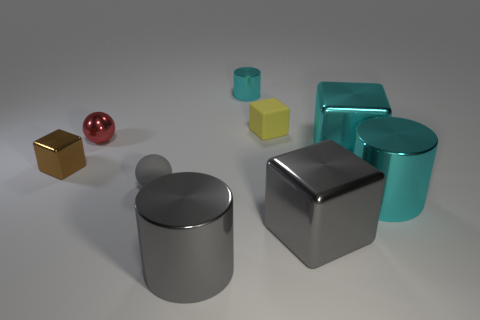What number of cyan cylinders are the same size as the brown metal cube?
Your answer should be very brief. 1. There is a big gray metallic object to the right of the small yellow matte thing; does it have the same shape as the matte object that is to the left of the small metallic cylinder?
Your answer should be very brief. No. What color is the small matte object to the right of the small object that is behind the yellow thing?
Provide a short and direct response. Yellow. What color is the other object that is the same shape as the red object?
Provide a short and direct response. Gray. The gray metal thing that is the same shape as the brown thing is what size?
Offer a very short reply. Large. There is a big gray thing right of the small cylinder; what material is it?
Ensure brevity in your answer.  Metal. Is the number of gray shiny objects behind the tiny brown block less than the number of purple metal objects?
Provide a short and direct response. No. There is a cyan object that is on the left side of the big thing that is behind the big cyan cylinder; what shape is it?
Your answer should be very brief. Cylinder. What is the color of the small metallic cube?
Keep it short and to the point. Brown. How many other objects are the same size as the red ball?
Your answer should be very brief. 4. 